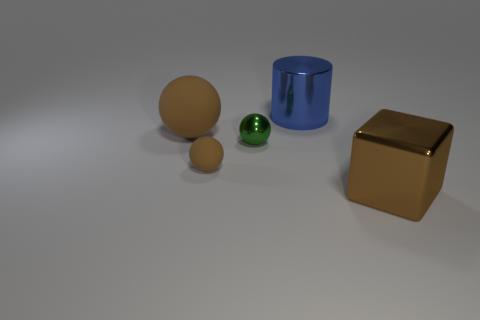The tiny matte ball is what color?
Your answer should be very brief. Brown. Is the color of the tiny ball that is left of the green thing the same as the large shiny object behind the small brown matte sphere?
Your answer should be very brief. No. How big is the green metal sphere?
Provide a short and direct response. Small. There is a metal thing that is behind the green metal ball; what is its size?
Your answer should be very brief. Large. The metal object that is to the left of the brown cube and on the right side of the green object has what shape?
Your response must be concise. Cylinder. What number of other things are the same shape as the tiny brown matte thing?
Make the answer very short. 2. What color is the other ball that is the same size as the green shiny sphere?
Ensure brevity in your answer.  Brown. What number of objects are either big blue shiny blocks or brown blocks?
Make the answer very short. 1. There is a metal sphere; are there any blue shiny objects in front of it?
Offer a very short reply. No. Are there any blue cylinders made of the same material as the big brown ball?
Make the answer very short. No. 